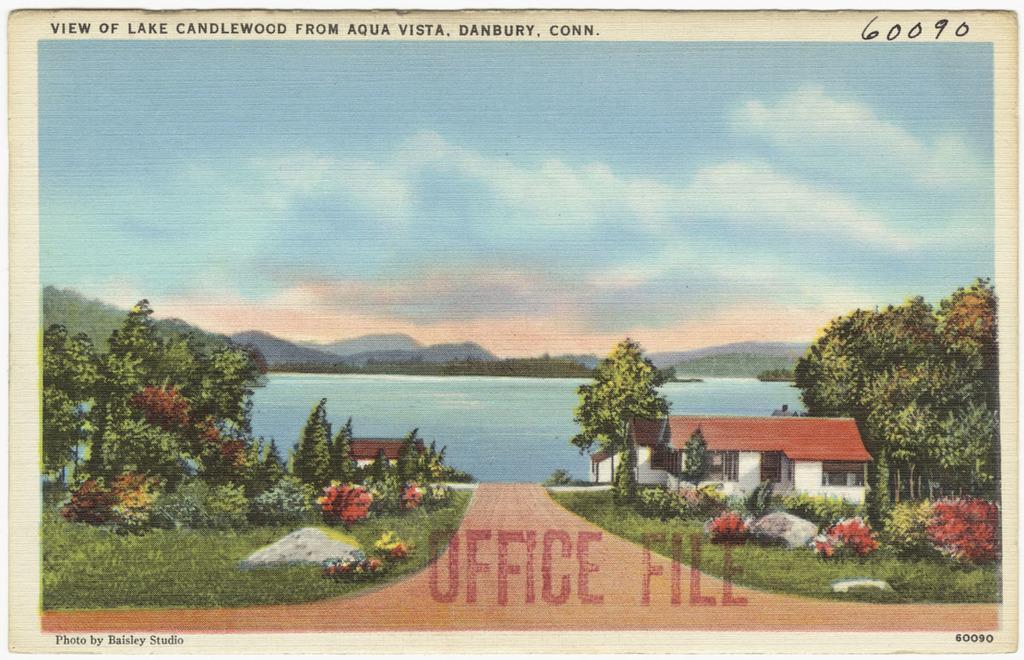In one or two sentences, can you explain what this image depicts? In the center of the image we can see a poster. On the poster, we can see the sky, clouds, hills, water, trees, buildings, windows, plants, grass and a road. And we can see some text on the poster. 